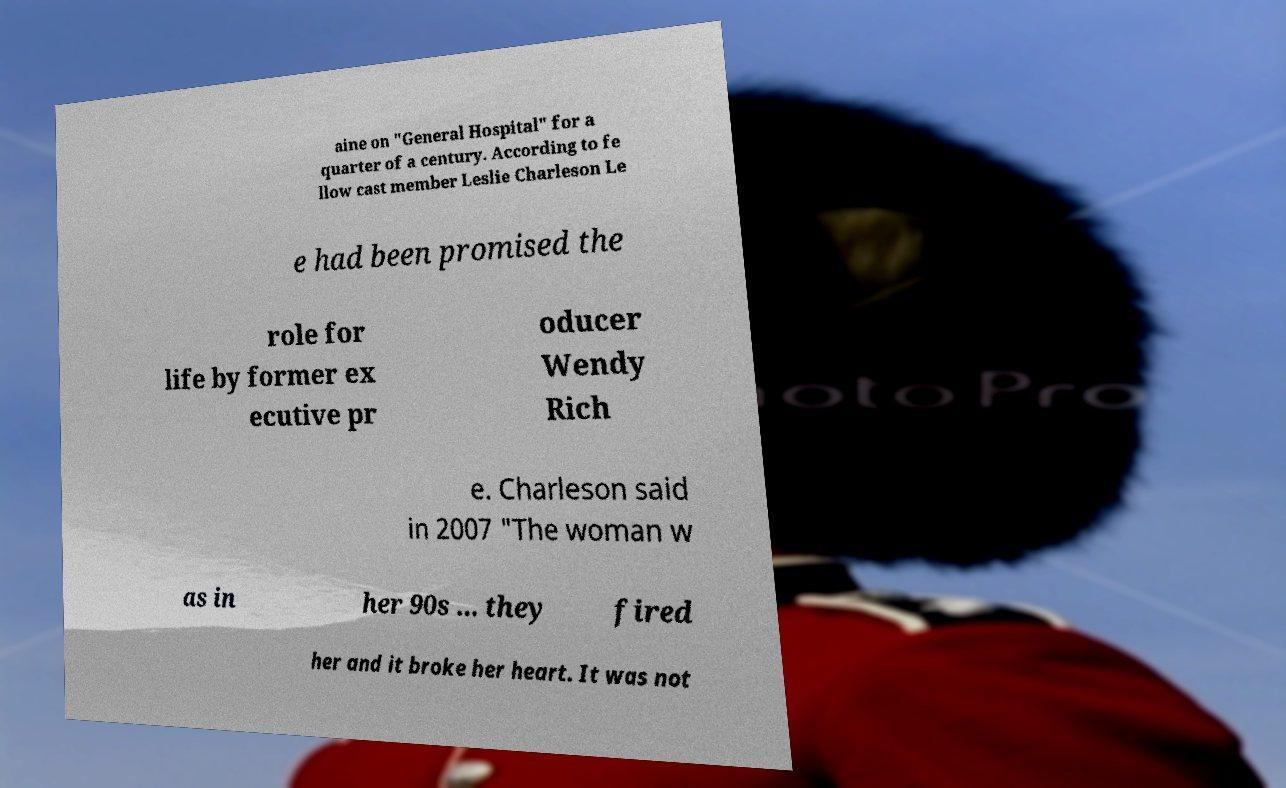What messages or text are displayed in this image? I need them in a readable, typed format. aine on "General Hospital" for a quarter of a century. According to fe llow cast member Leslie Charleson Le e had been promised the role for life by former ex ecutive pr oducer Wendy Rich e. Charleson said in 2007 "The woman w as in her 90s ... they fired her and it broke her heart. It was not 